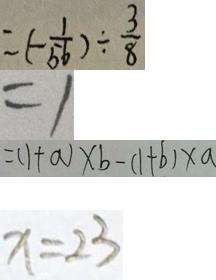<formula> <loc_0><loc_0><loc_500><loc_500>= ( - \frac { 1 } { 5 6 } ) \div \frac { 3 } { 8 } 
 = 1 
 = ( 1 + a ) \times b - ( 1 + b ) \times a 
 x = 2 3</formula> 